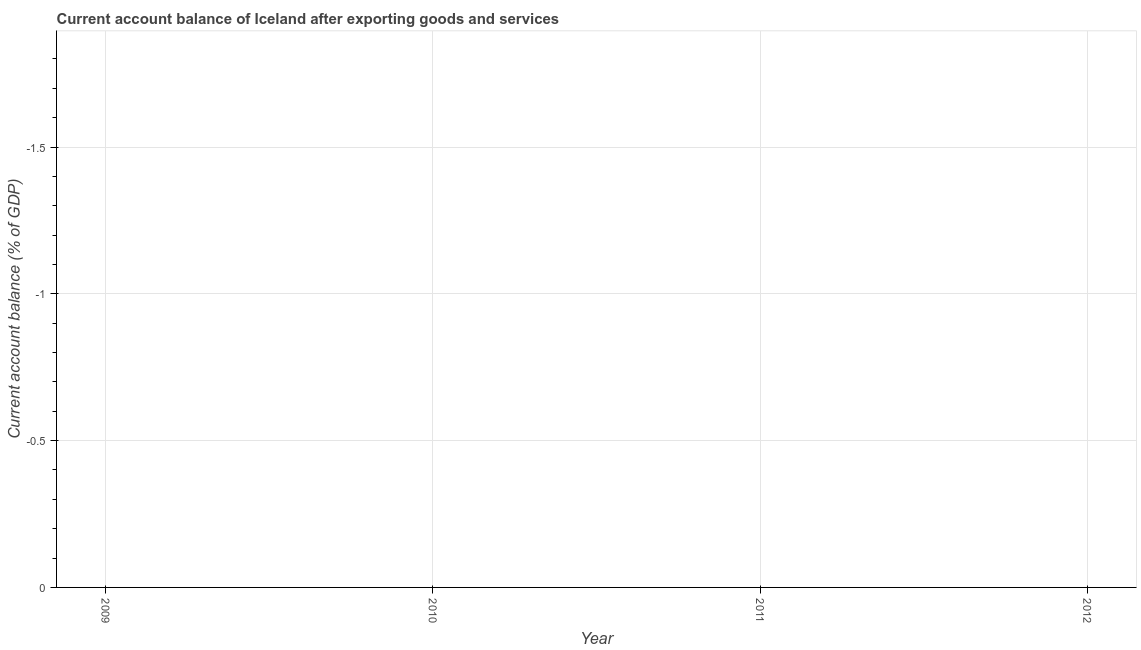What is the current account balance in 2010?
Ensure brevity in your answer.  0. What is the sum of the current account balance?
Provide a short and direct response. 0. In how many years, is the current account balance greater than -1.2 %?
Offer a terse response. 0. In how many years, is the current account balance greater than the average current account balance taken over all years?
Your answer should be very brief. 0. How many years are there in the graph?
Keep it short and to the point. 4. Does the graph contain any zero values?
Ensure brevity in your answer.  Yes. Does the graph contain grids?
Offer a terse response. Yes. What is the title of the graph?
Give a very brief answer. Current account balance of Iceland after exporting goods and services. What is the label or title of the X-axis?
Your response must be concise. Year. What is the label or title of the Y-axis?
Offer a terse response. Current account balance (% of GDP). What is the Current account balance (% of GDP) of 2010?
Provide a succinct answer. 0. 